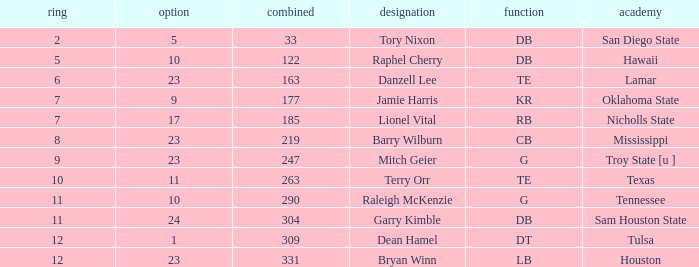Which Overall is the highest one that has a Name of raleigh mckenzie, and a Pick larger than 10? None. 